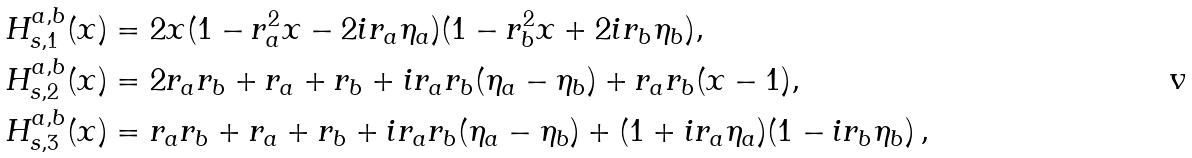Convert formula to latex. <formula><loc_0><loc_0><loc_500><loc_500>H ^ { a , b } _ { s , 1 } ( x ) & = 2 x ( 1 - r _ { a } ^ { 2 } x - 2 i r _ { a } \eta _ { a } ) ( 1 - r _ { b } ^ { 2 } x + 2 i r _ { b } \eta _ { b } ) , \\ H ^ { a , b } _ { s , 2 } ( x ) & = 2 r _ { a } r _ { b } + r _ { a } + r _ { b } + i r _ { a } r _ { b } ( \eta _ { a } - \eta _ { b } ) + r _ { a } r _ { b } ( x - 1 ) , \\ H ^ { a , b } _ { s , 3 } ( x ) & = r _ { a } r _ { b } + r _ { a } + r _ { b } + i r _ { a } r _ { b } ( \eta _ { a } - \eta _ { b } ) + ( 1 + i r _ { a } \eta _ { a } ) ( 1 - i r _ { b } \eta _ { b } ) \, ,</formula> 